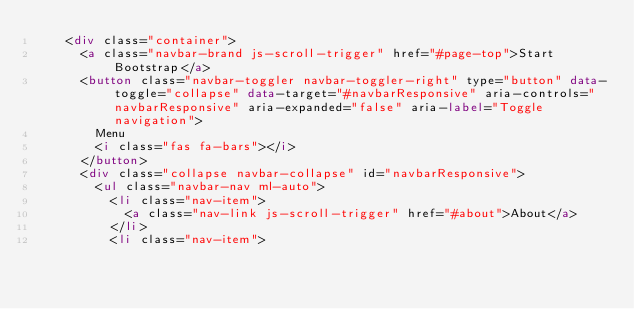Convert code to text. <code><loc_0><loc_0><loc_500><loc_500><_HTML_>    <div class="container">
      <a class="navbar-brand js-scroll-trigger" href="#page-top">Start Bootstrap</a>
      <button class="navbar-toggler navbar-toggler-right" type="button" data-toggle="collapse" data-target="#navbarResponsive" aria-controls="navbarResponsive" aria-expanded="false" aria-label="Toggle navigation">
        Menu
        <i class="fas fa-bars"></i>
      </button>
      <div class="collapse navbar-collapse" id="navbarResponsive">
        <ul class="navbar-nav ml-auto">
          <li class="nav-item">
            <a class="nav-link js-scroll-trigger" href="#about">About</a>
          </li>
          <li class="nav-item"></code> 